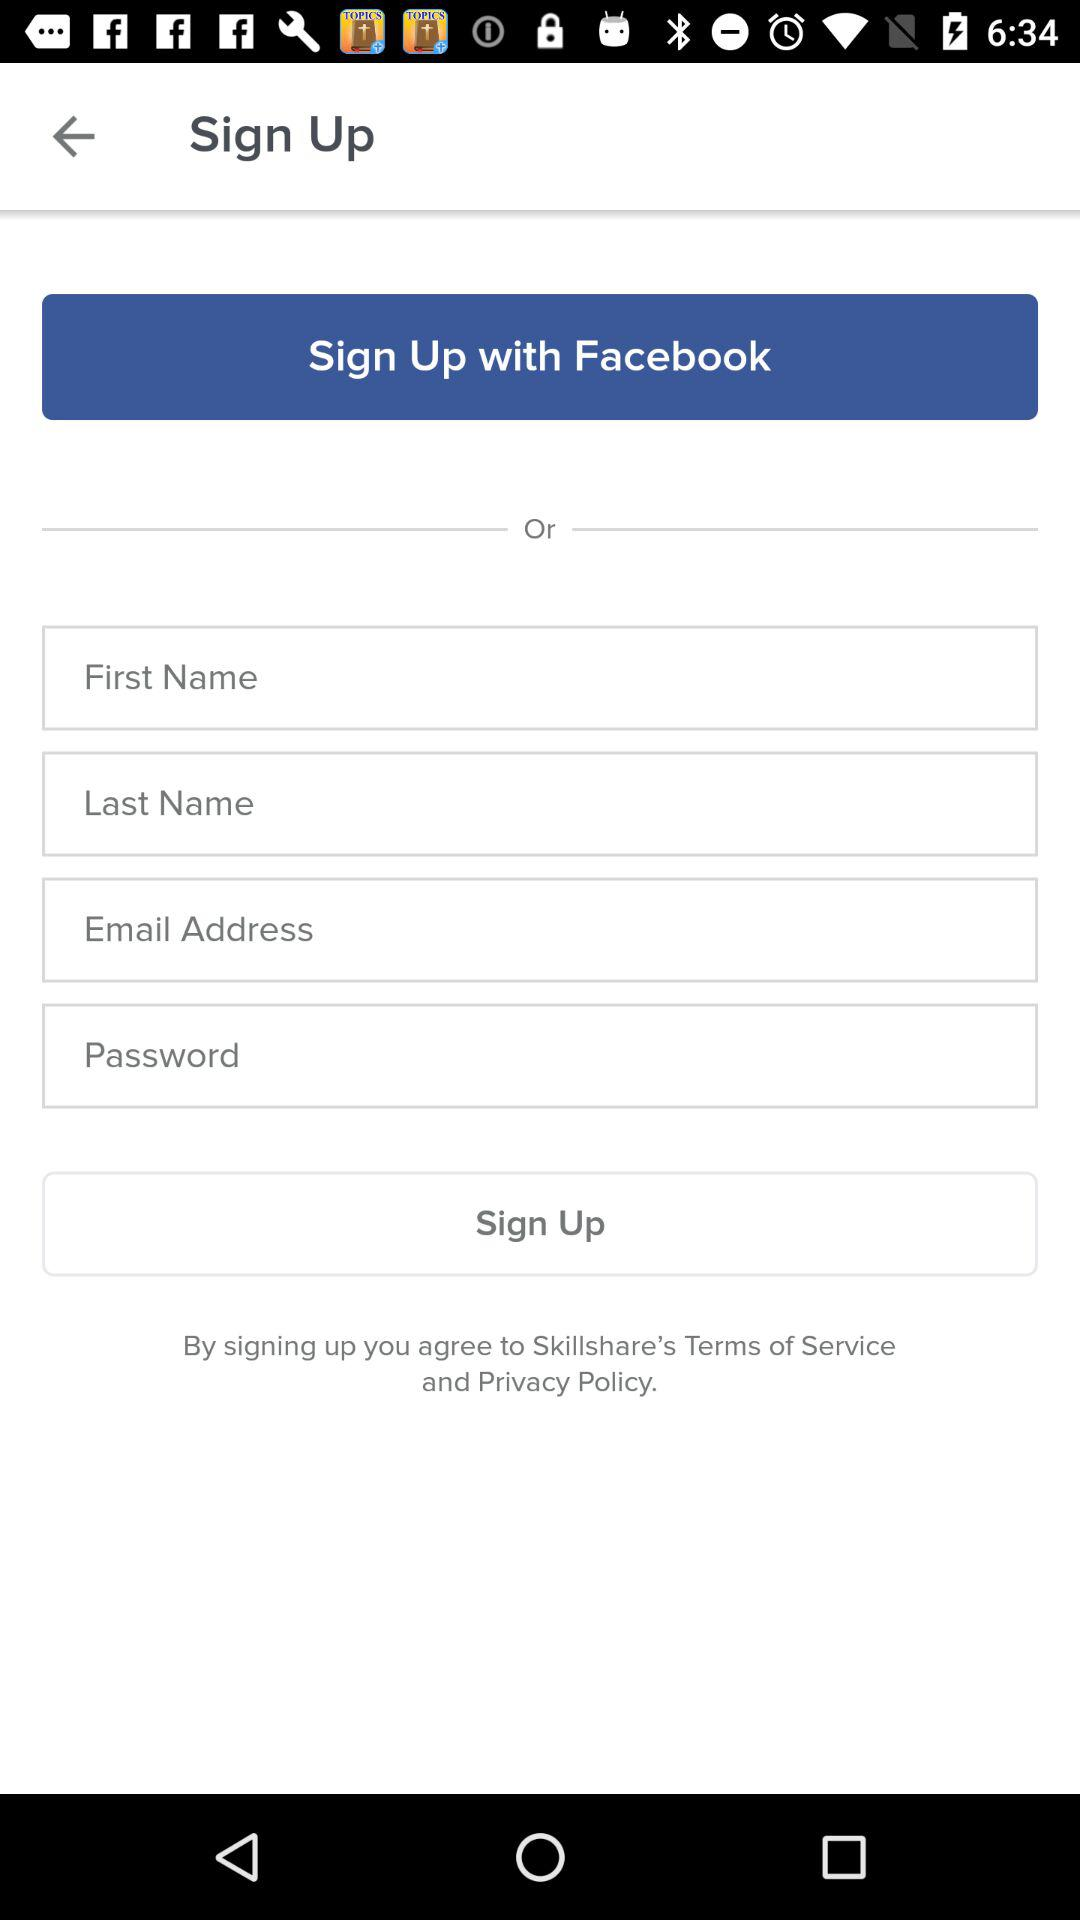What application can be used to sign up for the profile? The application that can be used to sign up for the profile is "Facebook". 